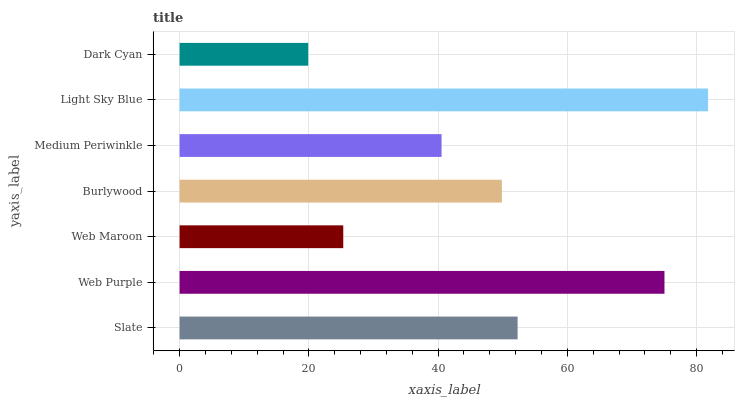Is Dark Cyan the minimum?
Answer yes or no. Yes. Is Light Sky Blue the maximum?
Answer yes or no. Yes. Is Web Purple the minimum?
Answer yes or no. No. Is Web Purple the maximum?
Answer yes or no. No. Is Web Purple greater than Slate?
Answer yes or no. Yes. Is Slate less than Web Purple?
Answer yes or no. Yes. Is Slate greater than Web Purple?
Answer yes or no. No. Is Web Purple less than Slate?
Answer yes or no. No. Is Burlywood the high median?
Answer yes or no. Yes. Is Burlywood the low median?
Answer yes or no. Yes. Is Web Maroon the high median?
Answer yes or no. No. Is Light Sky Blue the low median?
Answer yes or no. No. 